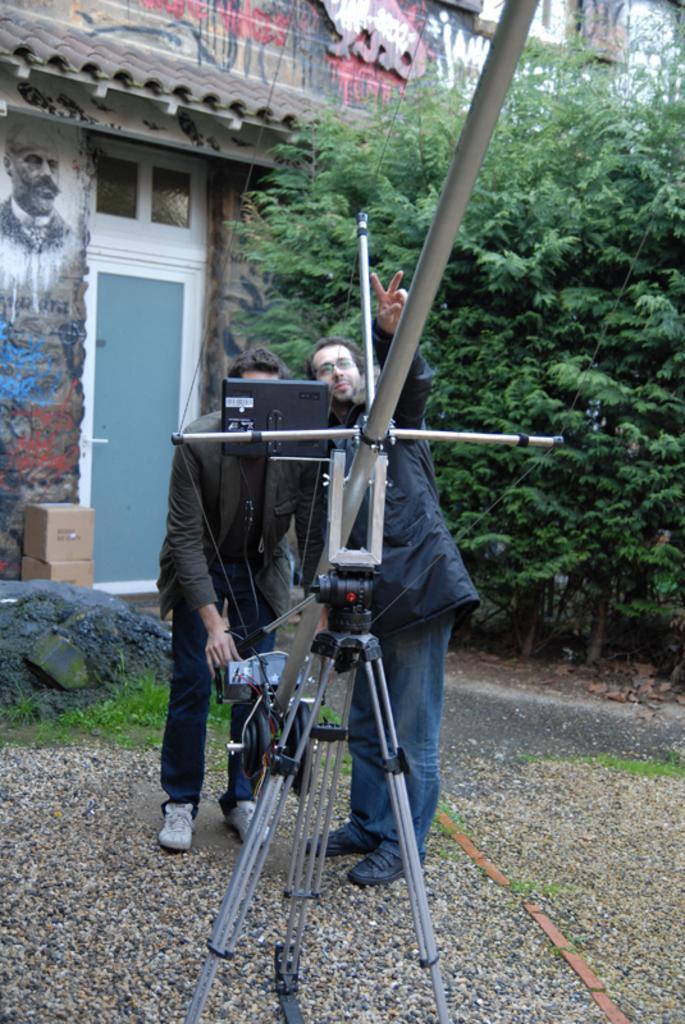How would you summarize this image in a sentence or two? In this image we can see two persons are standing on the ground, in front there is the stand, there are the trees, there is the building, there is the door. 